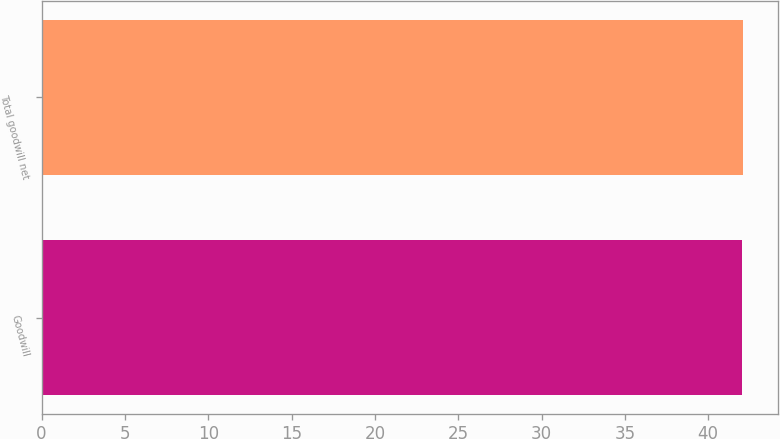Convert chart. <chart><loc_0><loc_0><loc_500><loc_500><bar_chart><fcel>Goodwill<fcel>Total goodwill net<nl><fcel>42<fcel>42.1<nl></chart> 